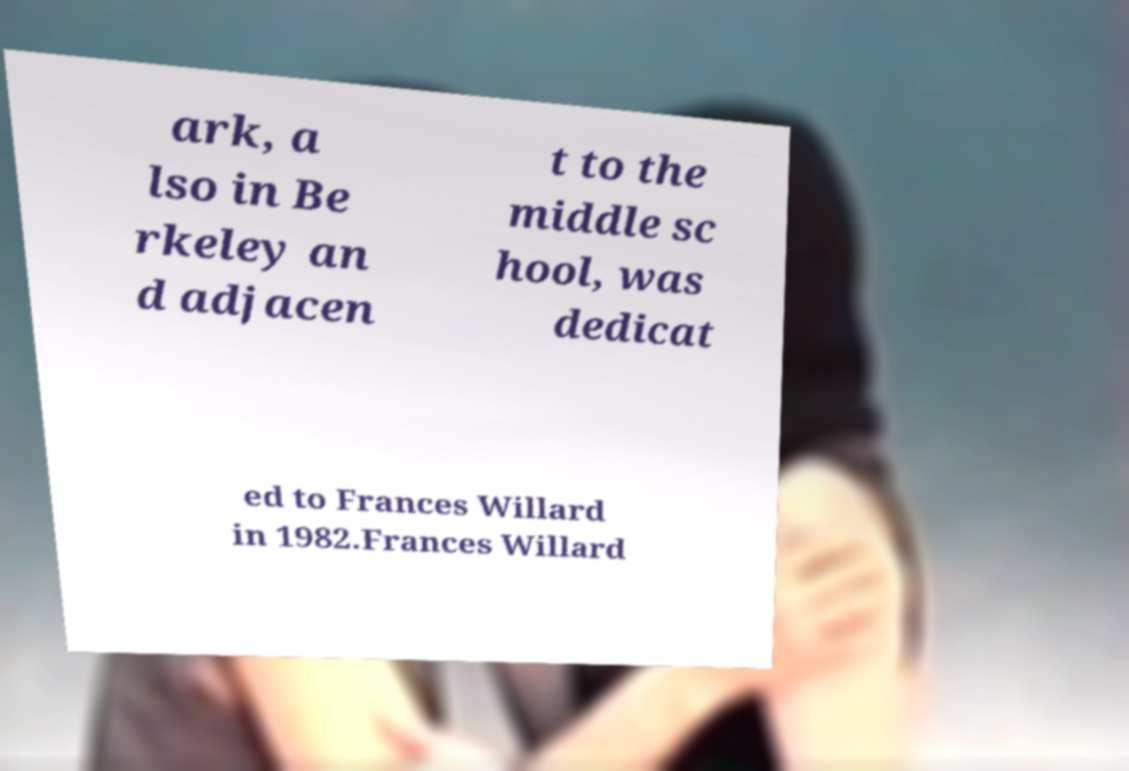I need the written content from this picture converted into text. Can you do that? ark, a lso in Be rkeley an d adjacen t to the middle sc hool, was dedicat ed to Frances Willard in 1982.Frances Willard 